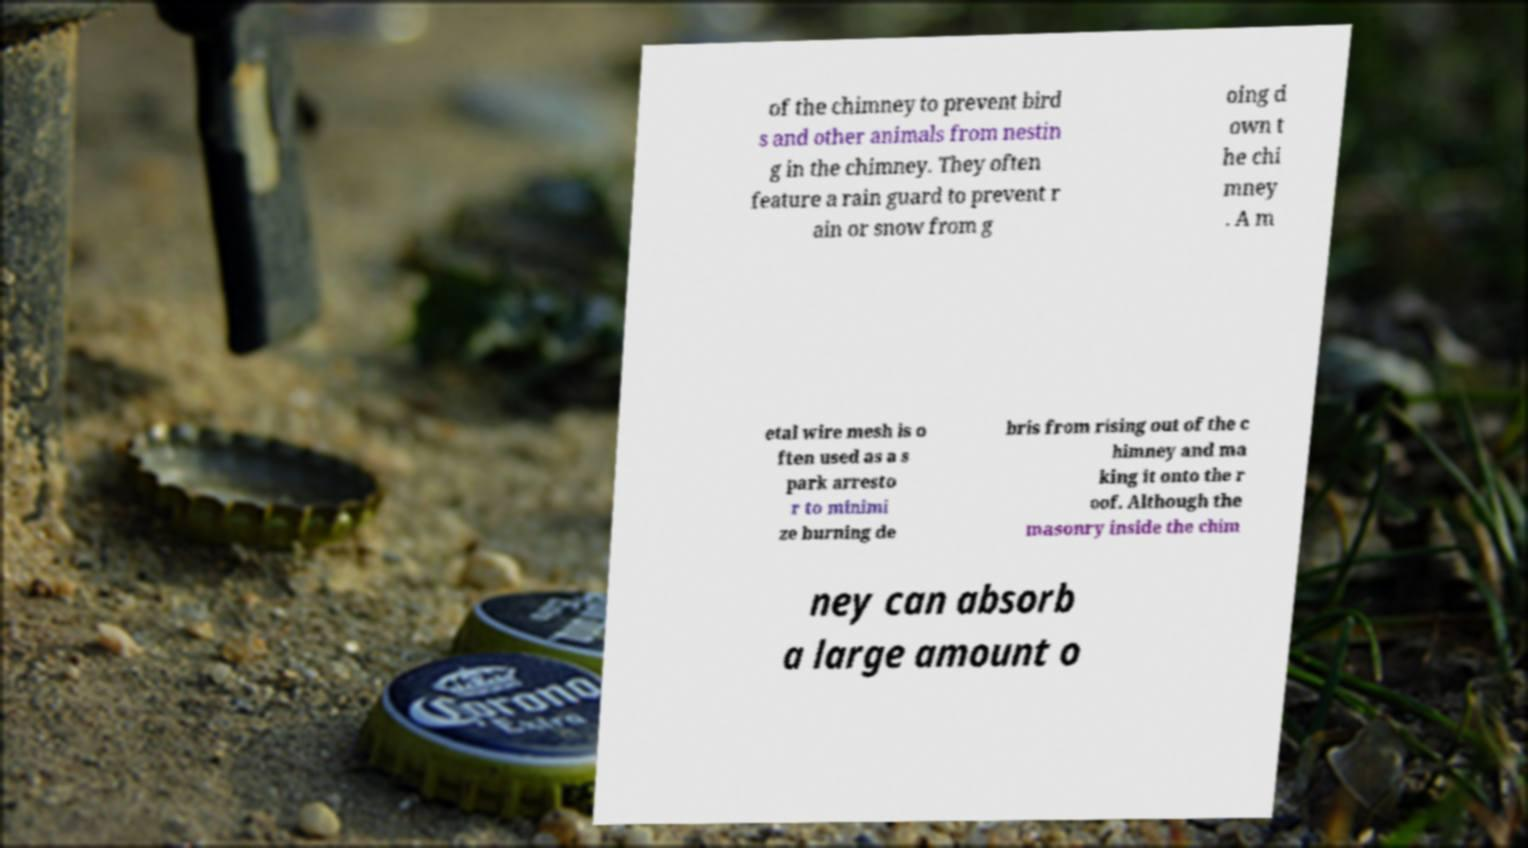Please identify and transcribe the text found in this image. of the chimney to prevent bird s and other animals from nestin g in the chimney. They often feature a rain guard to prevent r ain or snow from g oing d own t he chi mney . A m etal wire mesh is o ften used as a s park arresto r to minimi ze burning de bris from rising out of the c himney and ma king it onto the r oof. Although the masonry inside the chim ney can absorb a large amount o 